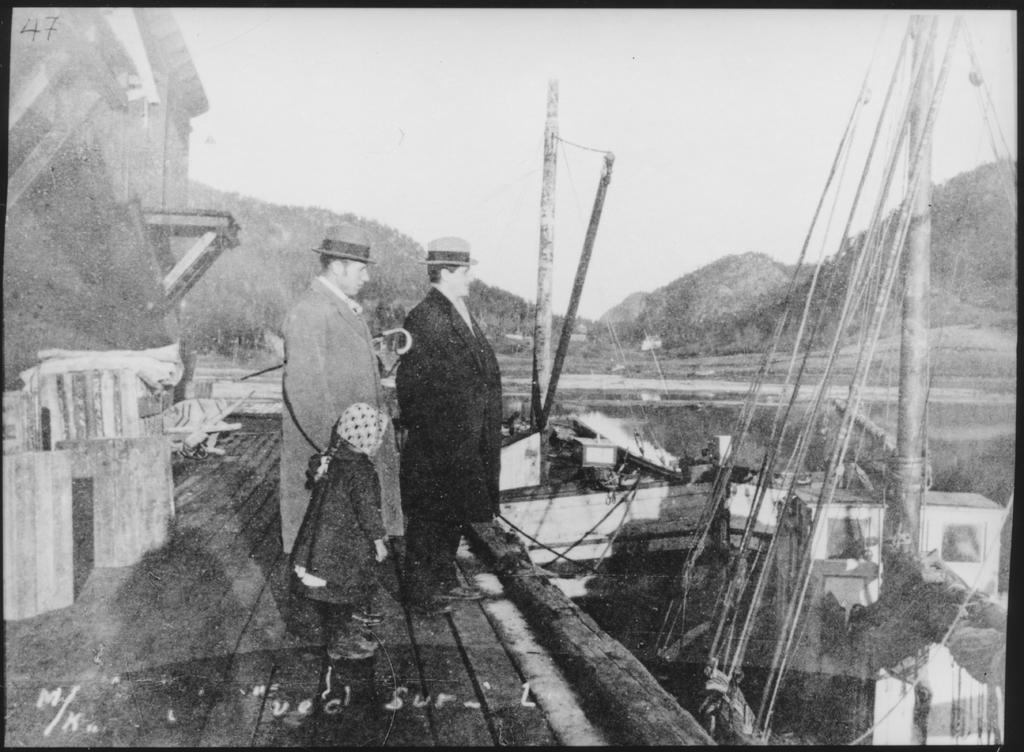Who or what is present in the image? There are people in the image. What are the people wearing on their heads? The people are wearing caps. What can be seen in front of the people? There are boats in front of the people. What is visible in the distance behind the people? There are hills visible in the background. How is the image presented in terms of color? The image is in black and white. What type of powder is being used to season the stew in the image? There is no stew or powder present in the image; it features people wearing caps, boats, and hills in the background. 